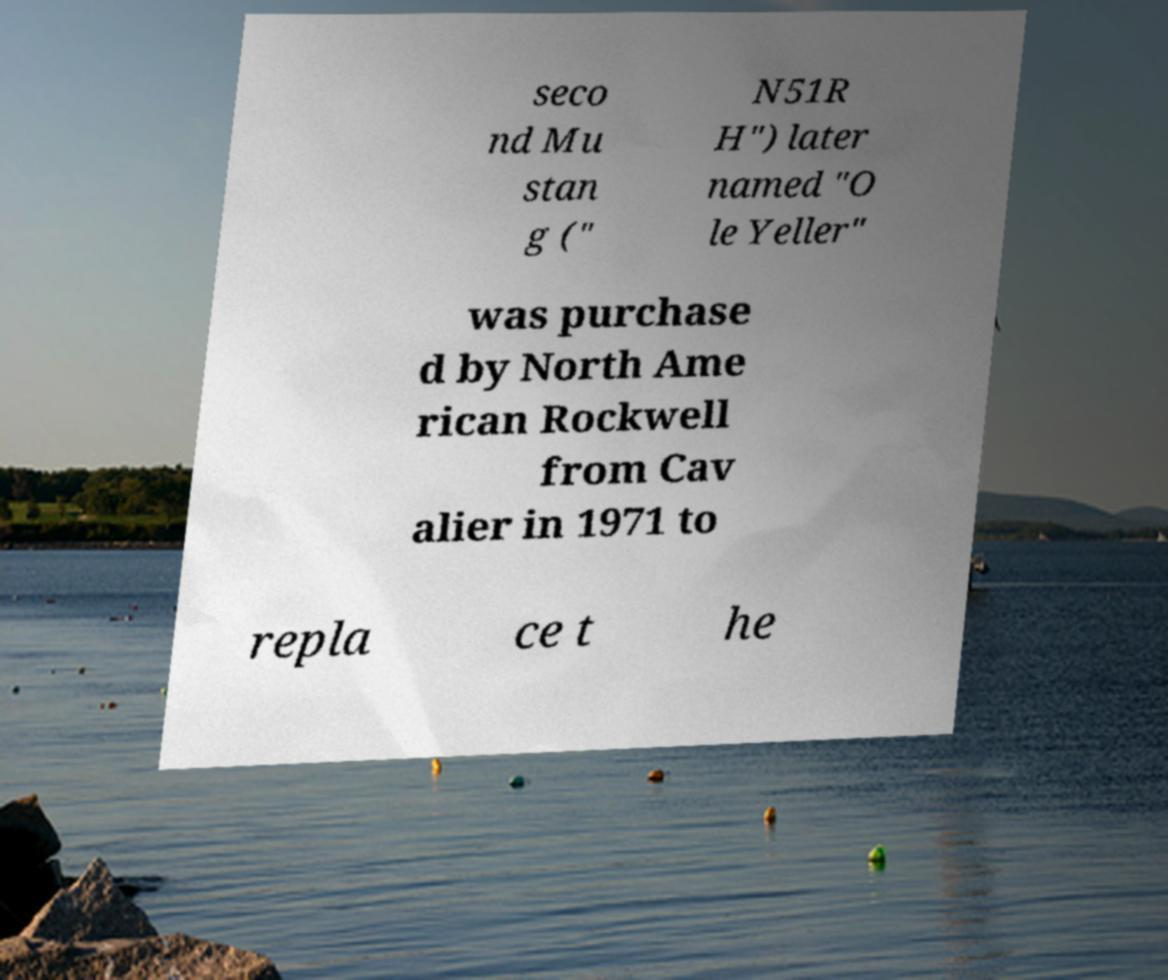Please read and relay the text visible in this image. What does it say? seco nd Mu stan g (" N51R H") later named "O le Yeller" was purchase d by North Ame rican Rockwell from Cav alier in 1971 to repla ce t he 